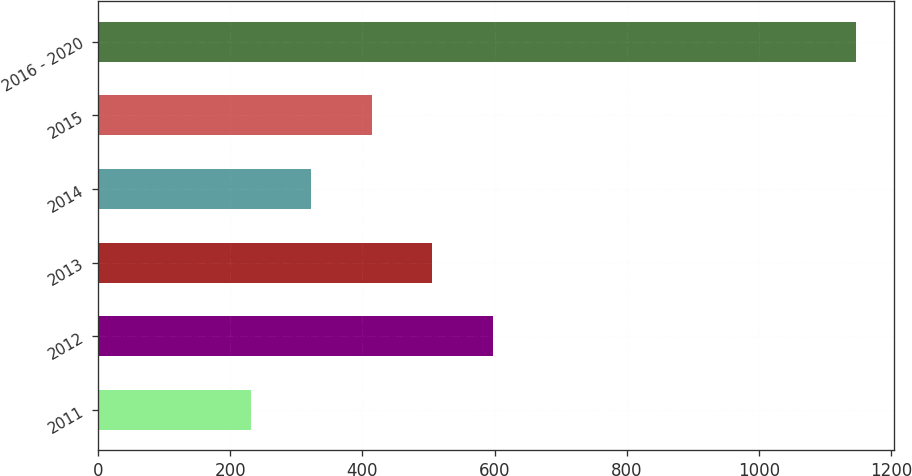Convert chart to OTSL. <chart><loc_0><loc_0><loc_500><loc_500><bar_chart><fcel>2011<fcel>2012<fcel>2013<fcel>2014<fcel>2015<fcel>2016 - 2020<nl><fcel>231<fcel>597.4<fcel>505.8<fcel>322.6<fcel>414.2<fcel>1147<nl></chart> 